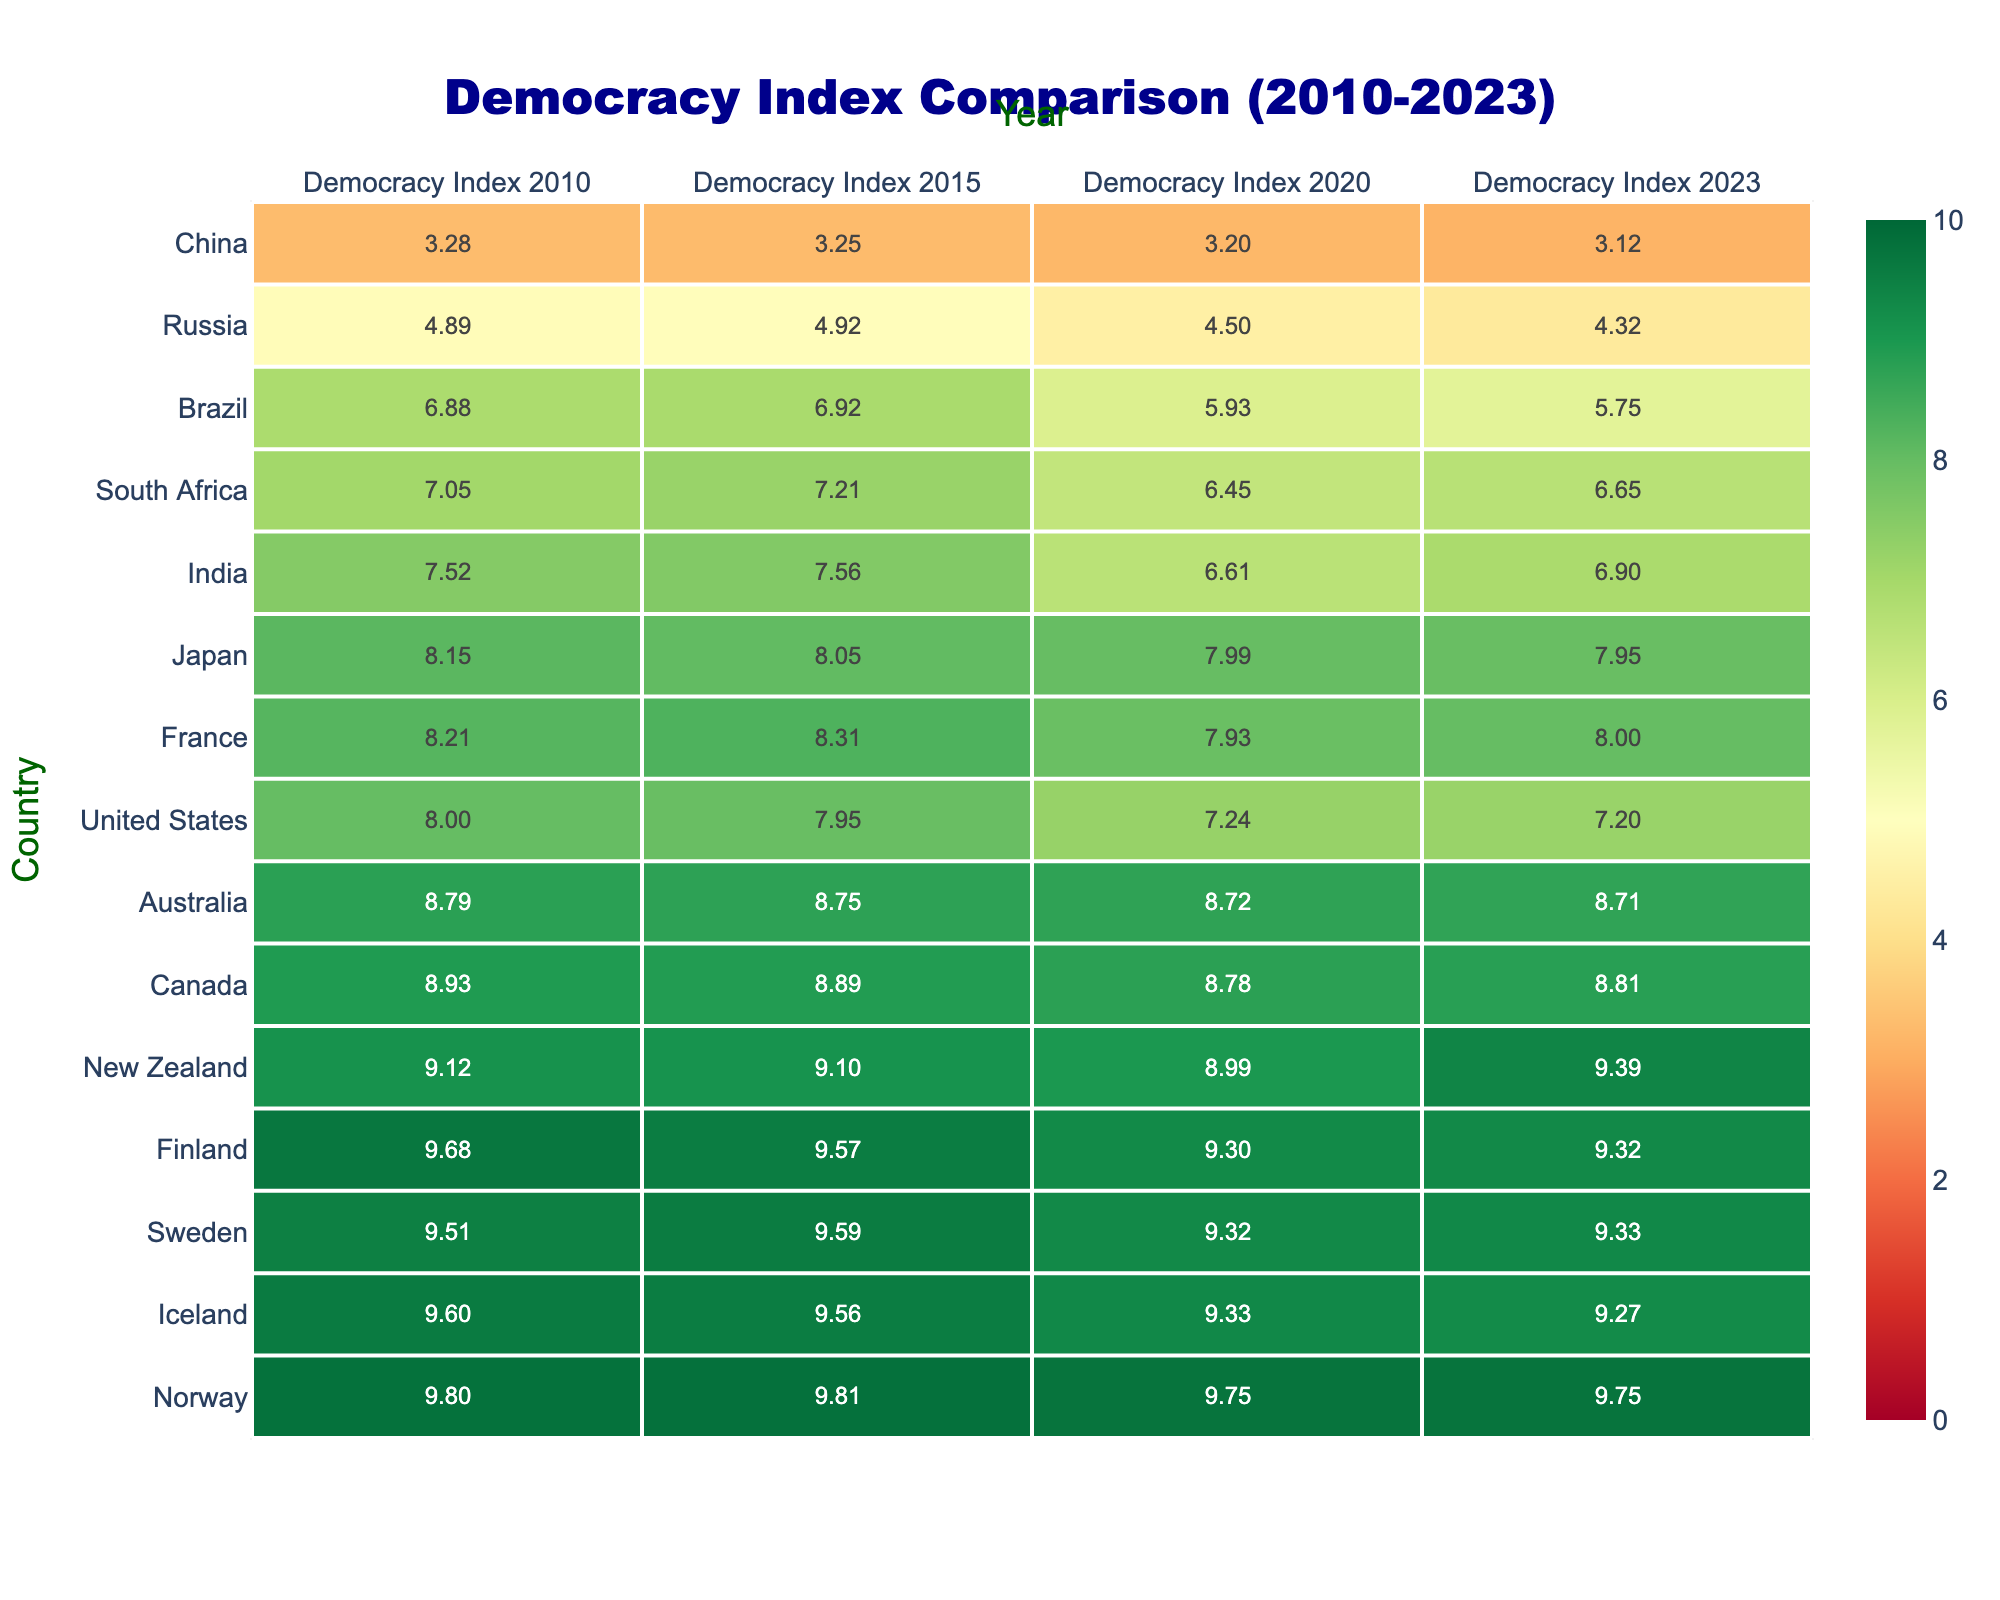What was the Democracy Index of Norway in 2020? From the data table, Norway's Democracy Index in 2020 is listed in the corresponding row, and it is 9.75.
Answer: 9.75 Which country showed the most significant decline in its Democracy Index from 2010 to 2023? By observing the changes for each country, Brazil's Democracy Index decreased from 6.88 in 2010 to 5.75 in 2023, a decline of 1.13, which is greater than any other country's decline.
Answer: Brazil What was the average Democracy Index for the United States from 2010 to 2023? To calculate the average, we add the Democracy Indices from each year: (8.00 + 7.95 + 7.24 + 7.20) = 30.39. There are 4 values, so we divide by 4: 30.39 / 4 = 7.5975, rounded to two decimal places gives 7.60.
Answer: 7.60 Is it true that Japan had a higher Democracy Index than India in 2023? Referring to the table, Japan's Democracy Index in 2023 is 7.95, while India's is 6.90. Since 7.95 is greater than 6.90, the statement is true.
Answer: Yes What is the difference in the Democracy Index between the best and worst-rated countries in 2015? The top country in 2015 is Norway with 9.81, and the bottom is China with 3.25. The difference is calculated by subtracting: 9.81 - 3.25 = 6.56.
Answer: 6.56 Which country had the largest increase in its Democracy Index from 2020 to 2023? By examining the table, New Zealand increased from 8.99 in 2020 to 9.39 in 2023, resulting in a positive change of 0.40, which is the largest increase compared to the other countries.
Answer: New Zealand What was the trend in the Democracy Index for South Africa from 2010 to 2023? The Democracy Index for South Africa shows an increase from 7.05 in 2010 to 7.21 in 2015 followed by a decrease to 6.45 in 2020 and a slight recovery to 6.65 in 2023. Overall, it first increased, then decreased, and finally showed a small increase in the last data year.
Answer: Fluctuating Was the average Democracy Index of the top five rated countries higher than that of the bottom five countries in 2023? The average of the top five (Norway, Iceland, Sweden, Finland, New Zealand) in 2023 is (9.75 + 9.27 + 9.33 + 9.32 + 9.39)/5 = 9.412. The average for the bottom five (India, South Africa, Brazil, Russia, China) is (6.90 + 6.65 + 5.75 + 4.32 + 3.12)/5 = 5.748. Since 9.412 > 5.748, the statement is true.
Answer: Yes 